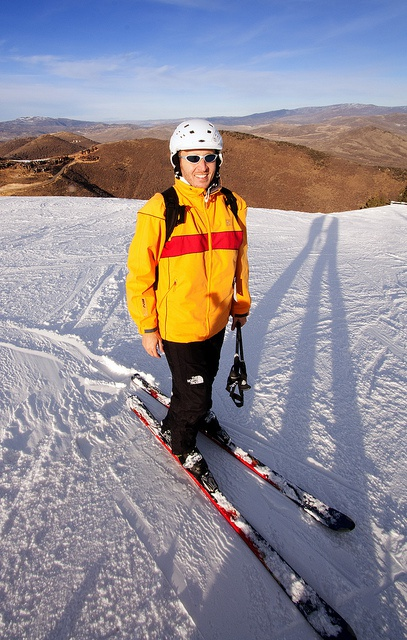Describe the objects in this image and their specific colors. I can see people in blue, black, gold, orange, and white tones and skis in blue, black, gray, lightgray, and darkgray tones in this image. 